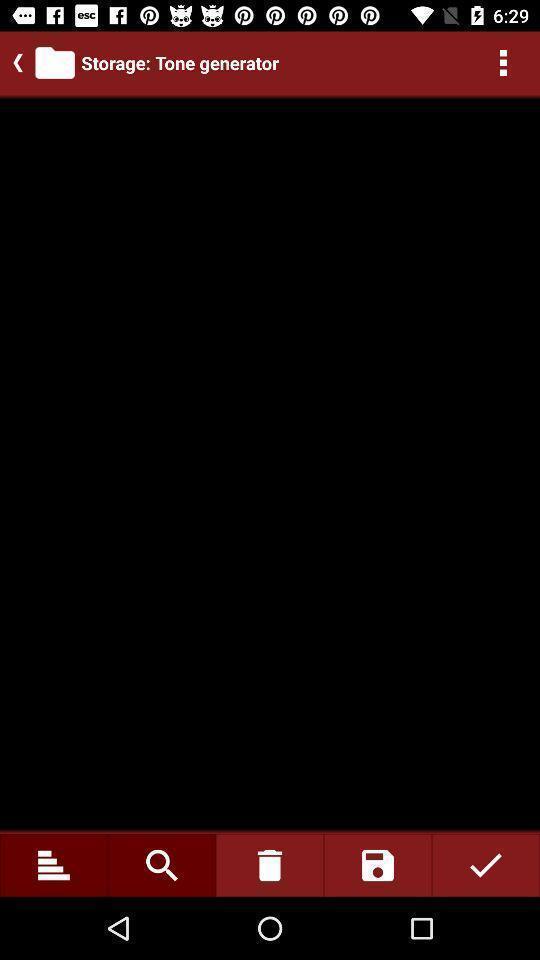Tell me what you see in this picture. Screen shows storage details. 